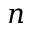<formula> <loc_0><loc_0><loc_500><loc_500>n</formula> 